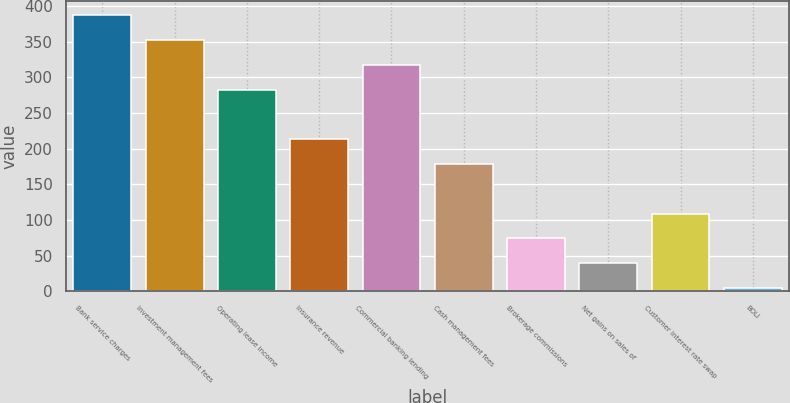<chart> <loc_0><loc_0><loc_500><loc_500><bar_chart><fcel>Bank service charges<fcel>Investment management fees<fcel>Operating lease income<fcel>Insurance revenue<fcel>Commercial banking lending<fcel>Cash management fees<fcel>Brokerage commissions<fcel>Net gains on sales of<fcel>Customer interest rate swap<fcel>BOLI<nl><fcel>387.18<fcel>352.4<fcel>282.84<fcel>213.28<fcel>317.62<fcel>178.5<fcel>74.16<fcel>39.38<fcel>108.94<fcel>4.6<nl></chart> 